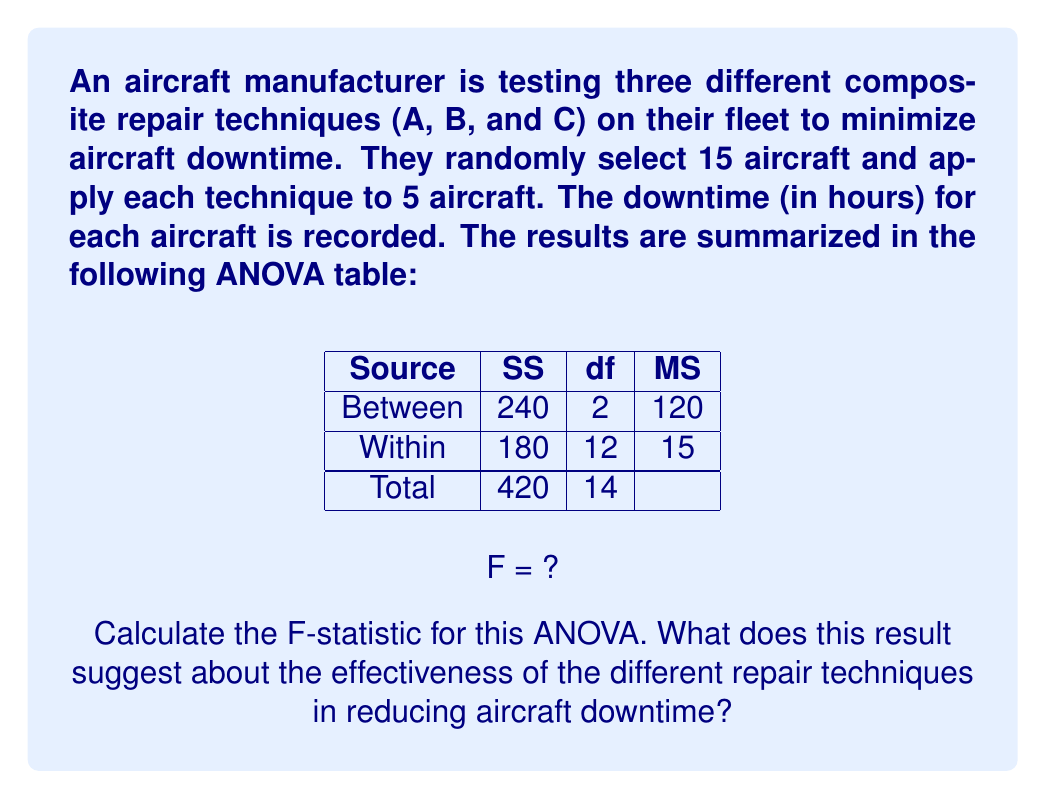What is the answer to this math problem? To calculate the F-statistic, we'll follow these steps:

1) The F-statistic is calculated as the ratio of the Mean Square Between (MSB) to the Mean Square Within (MSW):

   $$F = \frac{MSB}{MSW}$$

2) We are given MSB = 120 and MSW = 15 in the ANOVA table.

3) Substituting these values:

   $$F = \frac{120}{15} = 8$$

4) To interpret this result, we need to compare it to the critical F-value. For a significance level of 0.05, with 2 degrees of freedom for the numerator (between groups) and 12 degrees of freedom for the denominator (within groups), the critical F-value is approximately 3.89.

5) Since our calculated F-value (8) is greater than the critical F-value (3.89), we reject the null hypothesis.

6) This suggests that there is a statistically significant difference between the mean downtimes for the three repair techniques.

Interpretation: The F-statistic of 8 indicates that the variance between the groups (repair techniques) is 8 times larger than the variance within the groups. This provides strong evidence that the different repair techniques have significantly different effects on aircraft downtime. Therefore, the choice of repair technique appears to be an important factor in minimizing downtime.
Answer: F = 8; Significant difference between repair techniques' effectiveness. 